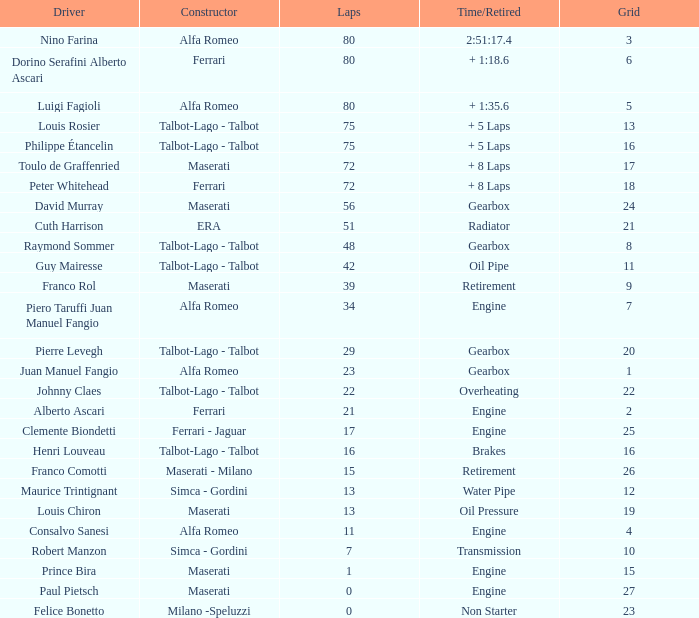6, who is the maker? Alfa Romeo. Can you parse all the data within this table? {'header': ['Driver', 'Constructor', 'Laps', 'Time/Retired', 'Grid'], 'rows': [['Nino Farina', 'Alfa Romeo', '80', '2:51:17.4', '3'], ['Dorino Serafini Alberto Ascari', 'Ferrari', '80', '+ 1:18.6', '6'], ['Luigi Fagioli', 'Alfa Romeo', '80', '+ 1:35.6', '5'], ['Louis Rosier', 'Talbot-Lago - Talbot', '75', '+ 5 Laps', '13'], ['Philippe Étancelin', 'Talbot-Lago - Talbot', '75', '+ 5 Laps', '16'], ['Toulo de Graffenried', 'Maserati', '72', '+ 8 Laps', '17'], ['Peter Whitehead', 'Ferrari', '72', '+ 8 Laps', '18'], ['David Murray', 'Maserati', '56', 'Gearbox', '24'], ['Cuth Harrison', 'ERA', '51', 'Radiator', '21'], ['Raymond Sommer', 'Talbot-Lago - Talbot', '48', 'Gearbox', '8'], ['Guy Mairesse', 'Talbot-Lago - Talbot', '42', 'Oil Pipe', '11'], ['Franco Rol', 'Maserati', '39', 'Retirement', '9'], ['Piero Taruffi Juan Manuel Fangio', 'Alfa Romeo', '34', 'Engine', '7'], ['Pierre Levegh', 'Talbot-Lago - Talbot', '29', 'Gearbox', '20'], ['Juan Manuel Fangio', 'Alfa Romeo', '23', 'Gearbox', '1'], ['Johnny Claes', 'Talbot-Lago - Talbot', '22', 'Overheating', '22'], ['Alberto Ascari', 'Ferrari', '21', 'Engine', '2'], ['Clemente Biondetti', 'Ferrari - Jaguar', '17', 'Engine', '25'], ['Henri Louveau', 'Talbot-Lago - Talbot', '16', 'Brakes', '16'], ['Franco Comotti', 'Maserati - Milano', '15', 'Retirement', '26'], ['Maurice Trintignant', 'Simca - Gordini', '13', 'Water Pipe', '12'], ['Louis Chiron', 'Maserati', '13', 'Oil Pressure', '19'], ['Consalvo Sanesi', 'Alfa Romeo', '11', 'Engine', '4'], ['Robert Manzon', 'Simca - Gordini', '7', 'Transmission', '10'], ['Prince Bira', 'Maserati', '1', 'Engine', '15'], ['Paul Pietsch', 'Maserati', '0', 'Engine', '27'], ['Felice Bonetto', 'Milano -Speluzzi', '0', 'Non Starter', '23']]} 